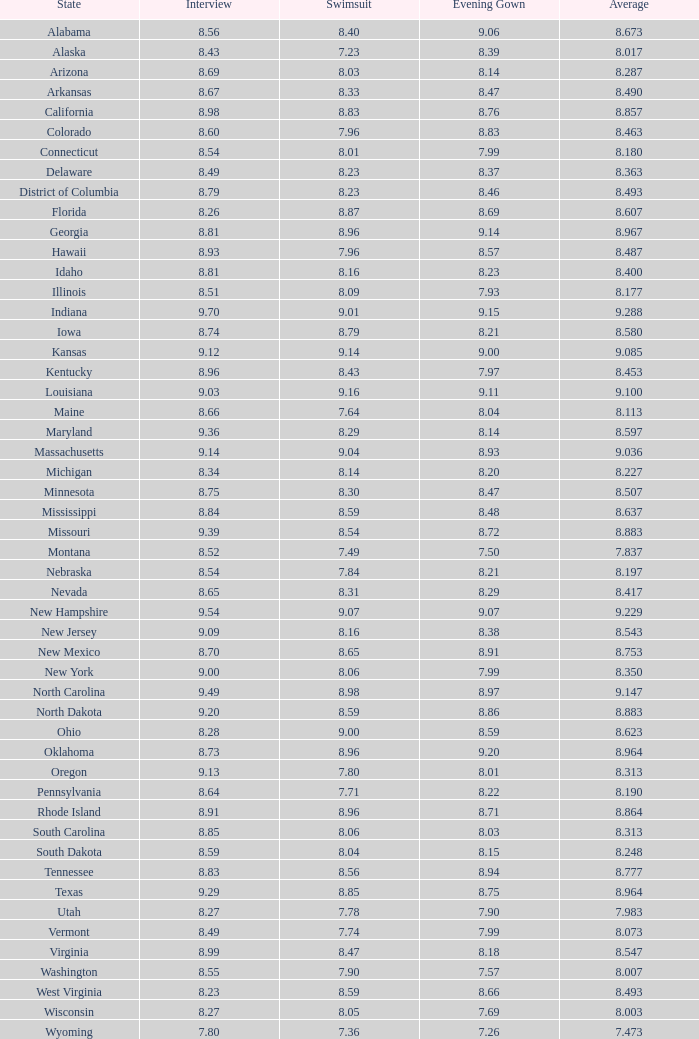Could you parse the entire table? {'header': ['State', 'Interview', 'Swimsuit', 'Evening Gown', 'Average'], 'rows': [['Alabama', '8.56', '8.40', '9.06', '8.673'], ['Alaska', '8.43', '7.23', '8.39', '8.017'], ['Arizona', '8.69', '8.03', '8.14', '8.287'], ['Arkansas', '8.67', '8.33', '8.47', '8.490'], ['California', '8.98', '8.83', '8.76', '8.857'], ['Colorado', '8.60', '7.96', '8.83', '8.463'], ['Connecticut', '8.54', '8.01', '7.99', '8.180'], ['Delaware', '8.49', '8.23', '8.37', '8.363'], ['District of Columbia', '8.79', '8.23', '8.46', '8.493'], ['Florida', '8.26', '8.87', '8.69', '8.607'], ['Georgia', '8.81', '8.96', '9.14', '8.967'], ['Hawaii', '8.93', '7.96', '8.57', '8.487'], ['Idaho', '8.81', '8.16', '8.23', '8.400'], ['Illinois', '8.51', '8.09', '7.93', '8.177'], ['Indiana', '9.70', '9.01', '9.15', '9.288'], ['Iowa', '8.74', '8.79', '8.21', '8.580'], ['Kansas', '9.12', '9.14', '9.00', '9.085'], ['Kentucky', '8.96', '8.43', '7.97', '8.453'], ['Louisiana', '9.03', '9.16', '9.11', '9.100'], ['Maine', '8.66', '7.64', '8.04', '8.113'], ['Maryland', '9.36', '8.29', '8.14', '8.597'], ['Massachusetts', '9.14', '9.04', '8.93', '9.036'], ['Michigan', '8.34', '8.14', '8.20', '8.227'], ['Minnesota', '8.75', '8.30', '8.47', '8.507'], ['Mississippi', '8.84', '8.59', '8.48', '8.637'], ['Missouri', '9.39', '8.54', '8.72', '8.883'], ['Montana', '8.52', '7.49', '7.50', '7.837'], ['Nebraska', '8.54', '7.84', '8.21', '8.197'], ['Nevada', '8.65', '8.31', '8.29', '8.417'], ['New Hampshire', '9.54', '9.07', '9.07', '9.229'], ['New Jersey', '9.09', '8.16', '8.38', '8.543'], ['New Mexico', '8.70', '8.65', '8.91', '8.753'], ['New York', '9.00', '8.06', '7.99', '8.350'], ['North Carolina', '9.49', '8.98', '8.97', '9.147'], ['North Dakota', '9.20', '8.59', '8.86', '8.883'], ['Ohio', '8.28', '9.00', '8.59', '8.623'], ['Oklahoma', '8.73', '8.96', '9.20', '8.964'], ['Oregon', '9.13', '7.80', '8.01', '8.313'], ['Pennsylvania', '8.64', '7.71', '8.22', '8.190'], ['Rhode Island', '8.91', '8.96', '8.71', '8.864'], ['South Carolina', '8.85', '8.06', '8.03', '8.313'], ['South Dakota', '8.59', '8.04', '8.15', '8.248'], ['Tennessee', '8.83', '8.56', '8.94', '8.777'], ['Texas', '9.29', '8.85', '8.75', '8.964'], ['Utah', '8.27', '7.78', '7.90', '7.983'], ['Vermont', '8.49', '7.74', '7.99', '8.073'], ['Virginia', '8.99', '8.47', '8.18', '8.547'], ['Washington', '8.55', '7.90', '7.57', '8.007'], ['West Virginia', '8.23', '8.59', '8.66', '8.493'], ['Wisconsin', '8.27', '8.05', '7.69', '8.003'], ['Wyoming', '7.80', '7.36', '7.26', '7.473']]} Identify the state with a night dress above Alabama. 